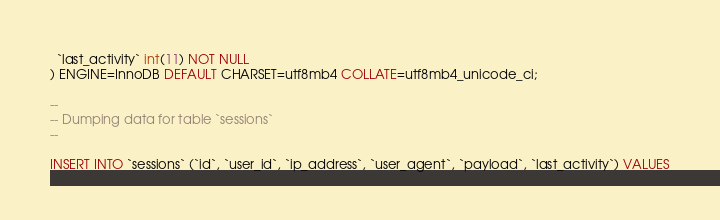<code> <loc_0><loc_0><loc_500><loc_500><_SQL_>  `last_activity` int(11) NOT NULL
) ENGINE=InnoDB DEFAULT CHARSET=utf8mb4 COLLATE=utf8mb4_unicode_ci;

--
-- Dumping data for table `sessions`
--

INSERT INTO `sessions` (`id`, `user_id`, `ip_address`, `user_agent`, `payload`, `last_activity`) VALUES</code> 